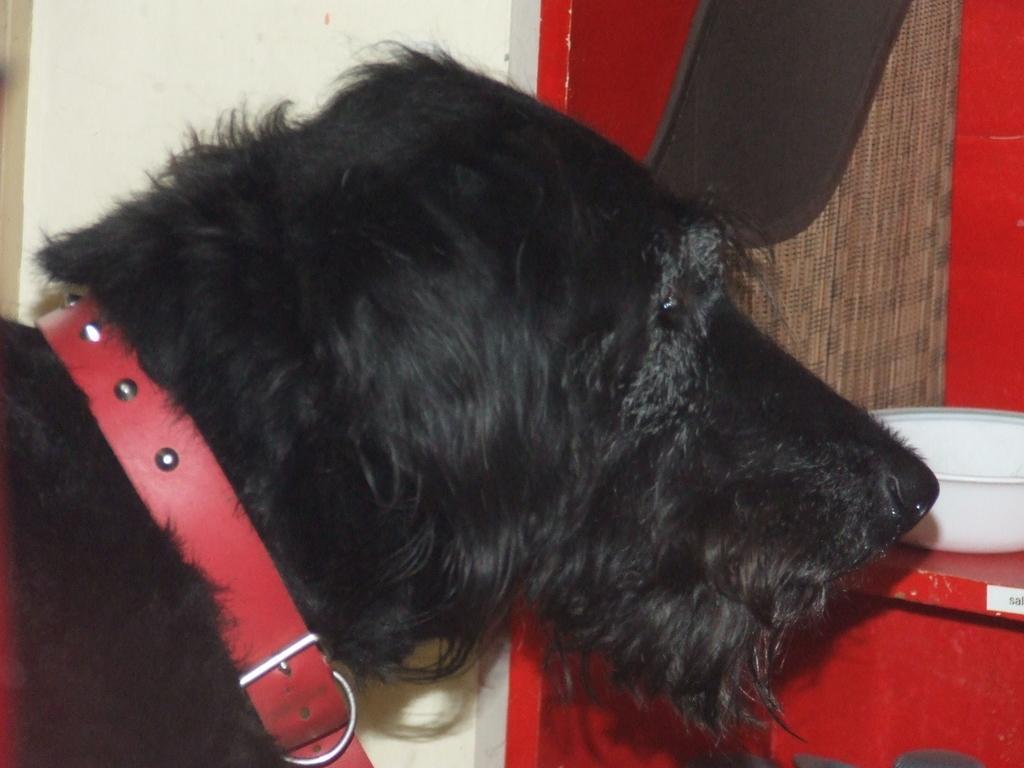Could you give a brief overview of what you see in this image? In this image we can see a dog and there is a belt around its neck. There is a bowl on an object. There is a black color object in the image. 